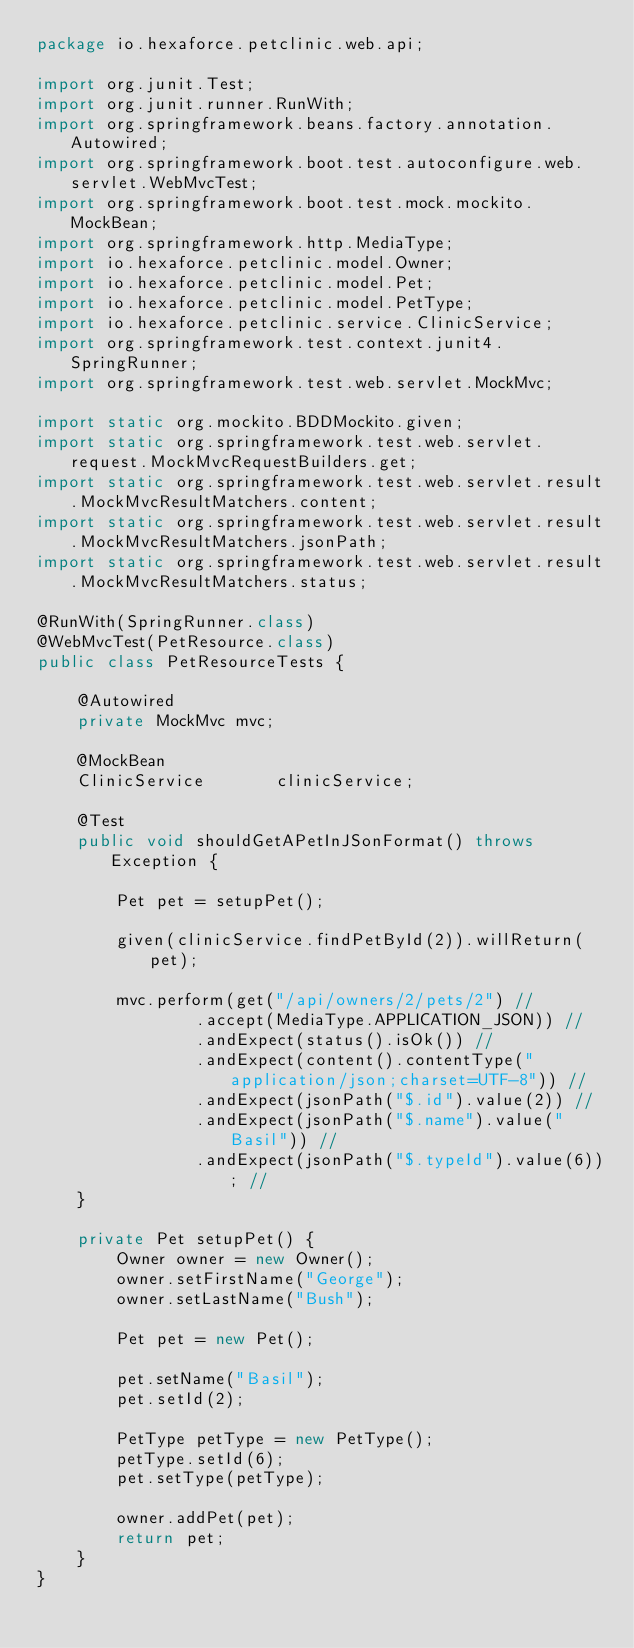Convert code to text. <code><loc_0><loc_0><loc_500><loc_500><_Java_>package io.hexaforce.petclinic.web.api;

import org.junit.Test;
import org.junit.runner.RunWith;
import org.springframework.beans.factory.annotation.Autowired;
import org.springframework.boot.test.autoconfigure.web.servlet.WebMvcTest;
import org.springframework.boot.test.mock.mockito.MockBean;
import org.springframework.http.MediaType;
import io.hexaforce.petclinic.model.Owner;
import io.hexaforce.petclinic.model.Pet;
import io.hexaforce.petclinic.model.PetType;
import io.hexaforce.petclinic.service.ClinicService;
import org.springframework.test.context.junit4.SpringRunner;
import org.springframework.test.web.servlet.MockMvc;

import static org.mockito.BDDMockito.given;
import static org.springframework.test.web.servlet.request.MockMvcRequestBuilders.get;
import static org.springframework.test.web.servlet.result.MockMvcResultMatchers.content;
import static org.springframework.test.web.servlet.result.MockMvcResultMatchers.jsonPath;
import static org.springframework.test.web.servlet.result.MockMvcResultMatchers.status;

@RunWith(SpringRunner.class)
@WebMvcTest(PetResource.class)
public class PetResourceTests {

	@Autowired
	private MockMvc	mvc;

	@MockBean
	ClinicService		clinicService;

	@Test
	public void shouldGetAPetInJSonFormat() throws Exception {

		Pet pet = setupPet();

		given(clinicService.findPetById(2)).willReturn(pet);

		mvc.perform(get("/api/owners/2/pets/2") //
				.accept(MediaType.APPLICATION_JSON)) //
				.andExpect(status().isOk()) //
				.andExpect(content().contentType("application/json;charset=UTF-8")) //
				.andExpect(jsonPath("$.id").value(2)) //
				.andExpect(jsonPath("$.name").value("Basil")) //
				.andExpect(jsonPath("$.typeId").value(6)); //
	}

	private Pet setupPet() {
		Owner owner = new Owner();
		owner.setFirstName("George");
		owner.setLastName("Bush");

		Pet pet = new Pet();

		pet.setName("Basil");
		pet.setId(2);

		PetType petType = new PetType();
		petType.setId(6);
		pet.setType(petType);

		owner.addPet(pet);
		return pet;
	}
}</code> 